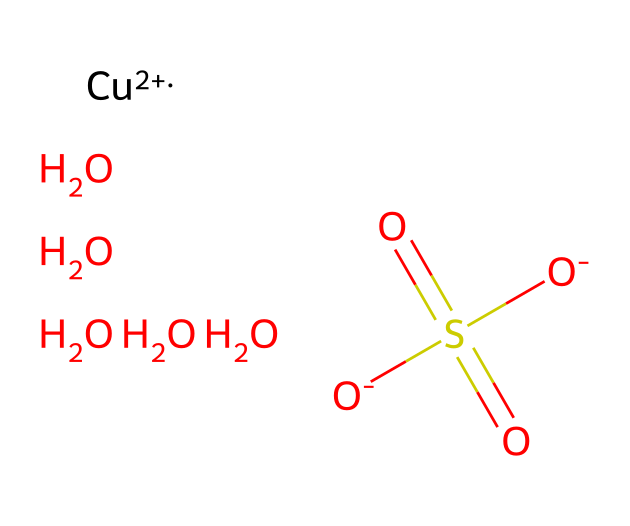How many oxygen atoms are in the chemical structure? In the given SMILES representation, there are five "O" symbols which indicate the presence of five oxygen atoms.
Answer: five What is the oxidation state of copper in this complex? The notation "[Cu+2]" indicates that copper has a +2 oxidation state.
Answer: +2 How many sulfate groups are present in the chemical? The structure contains one "S(=O)(=O)" which represents a single sulfate group.
Answer: one What type of bond is likely predominant in this coordination complex? Given that copper is coordinating with sulfur and multiple oxygen atoms, it suggests prevalent coordinate covalent bonding typical of coordination compounds.
Answer: coordinate covalent What is the total number of hydrogen atoms in the chemical? Analyzing the structure, there are five water molecules (each contributes 2 H atoms), resulting in ten hydrogen atoms total. Therefore, there are no explicit hydrogen atoms other than those in the water molecules.
Answer: ten What is the main agricultural use of this coordination complex? Copper sulfate pentahydrate is commonly used as a fungicide in agriculture to prevent various fungal diseases in crops.
Answer: fungicide 